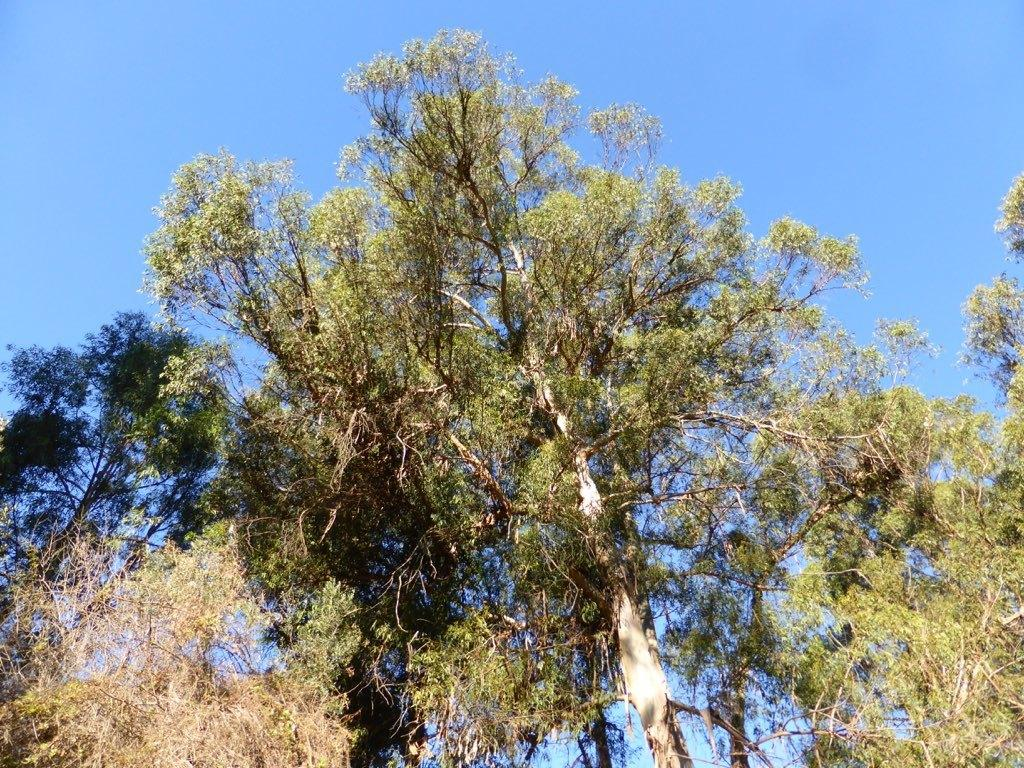What type of vegetation can be seen in the image? There are trees in the image. What part of the natural environment is visible in the image? The sky is visible in the background of the image. What is the income of the self-driving tank in the image? There is no self-driving tank present in the image, and therefore no income can be determined. 